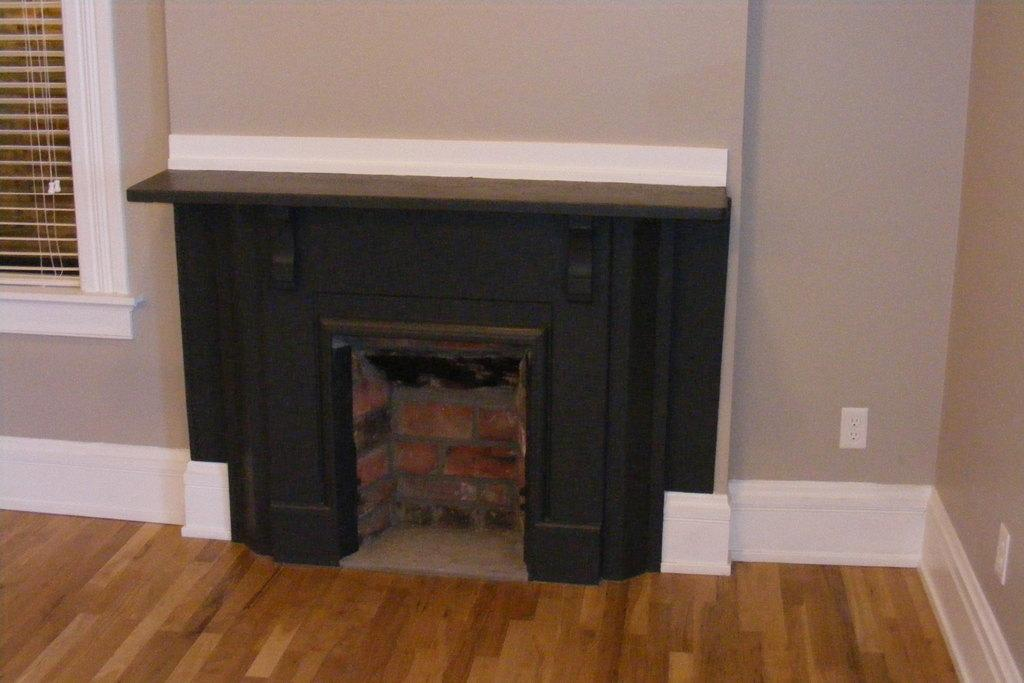Where was the image taken? The image is taken indoors. What can be seen at the bottom of the image? There is a floor visible at the bottom of the image. What is located in the middle of the image? There is a fireplace in the middle of the image. How many walls are visible in the image? There are two walls in the image. What is present on one of the walls? There is a window on one of the walls. Is there any window treatment associated with the window? Yes, there is a window blind associated with the window. What type of story is the judge telling in the image? There is no judge or story present in the image. Can you tell me how many dogs are visible in the image? There are no dogs present in the image. 